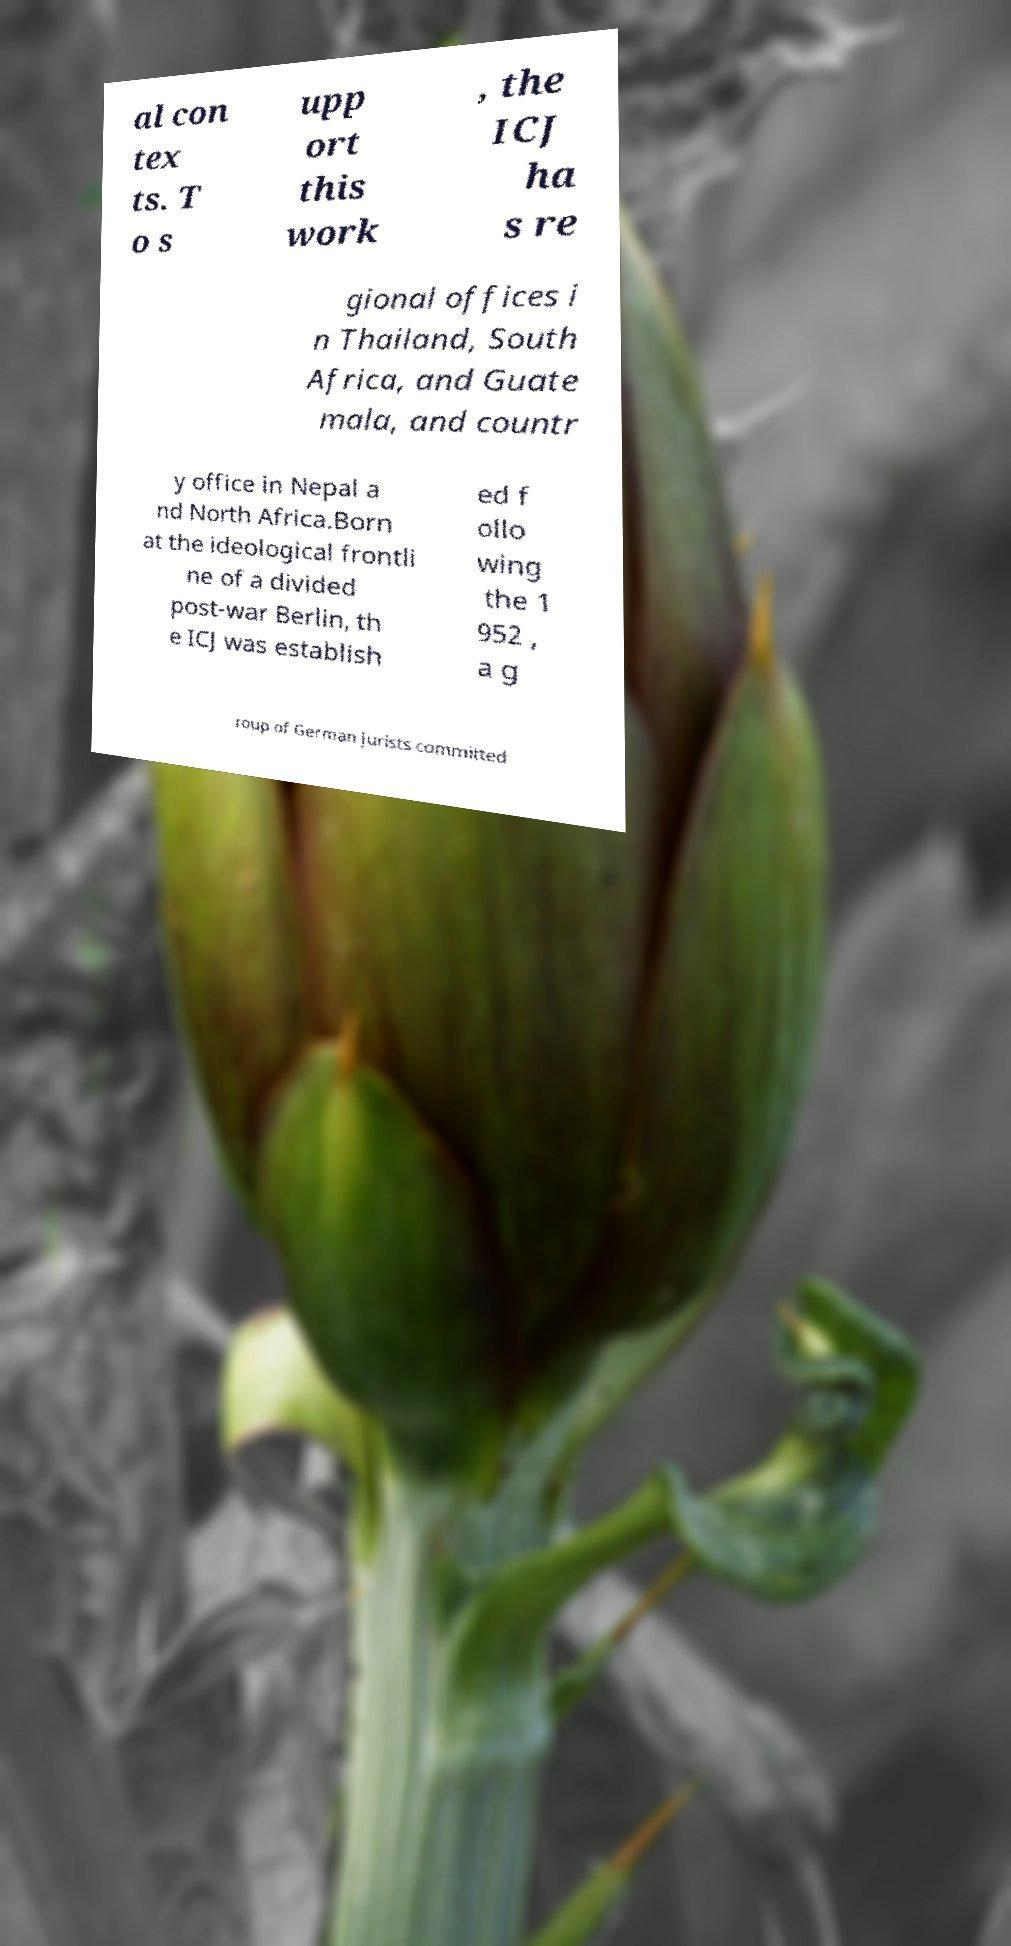There's text embedded in this image that I need extracted. Can you transcribe it verbatim? al con tex ts. T o s upp ort this work , the ICJ ha s re gional offices i n Thailand, South Africa, and Guate mala, and countr y office in Nepal a nd North Africa.Born at the ideological frontli ne of a divided post-war Berlin, th e ICJ was establish ed f ollo wing the 1 952 , a g roup of German jurists committed 